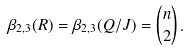Convert formula to latex. <formula><loc_0><loc_0><loc_500><loc_500>\beta _ { 2 , 3 } ( R ) = \beta _ { 2 , 3 } ( Q / J ) = \binom { n } { 2 } \, .</formula> 